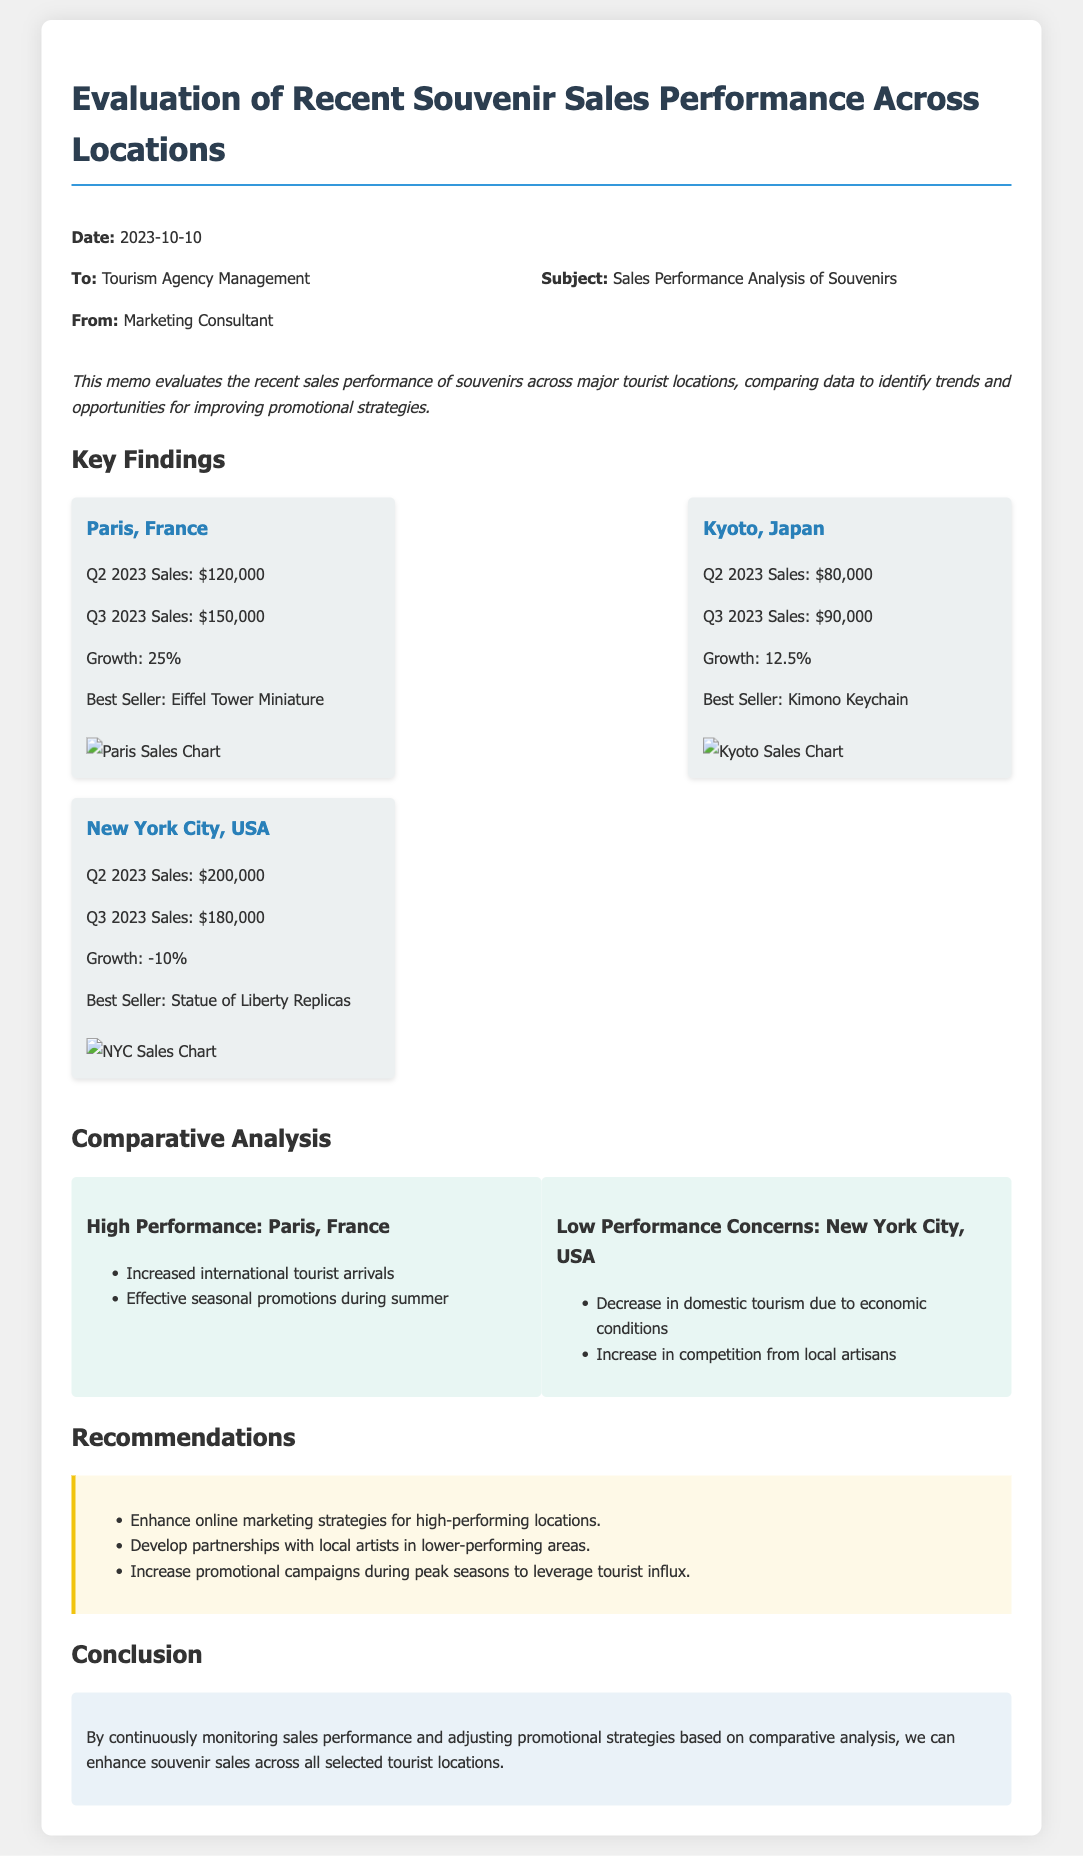What was the sales growth percentage for Paris? The growth for Paris is specifically stated as 25% in the key findings section.
Answer: 25% What is the best-selling souvenir in Kyoto? The document mentions the Kimono Keychain as the best seller in Kyoto.
Answer: Kimono Keychain What were the Q2 2023 sales figures for New York City? The Q2 2023 sales for New York City are provided, which is $200,000.
Answer: $200,000 What are the two main factors mentioned for Paris's high performance? The report lists increased international tourist arrivals and effective seasonal promotions as factors for Paris's success.
Answer: Increased international tourist arrivals, effective seasonal promotions What recommendations are given for low-performing areas? The recommendations included developing partnerships with local artists in areas with lower performance.
Answer: Develop partnerships with local artists What growth trend is observed in Kyoto? The document shows a growth of 12.5% for Kyoto in the recent analysis.
Answer: 12.5% What is the conclusion mentioned in the memo? The conclusion states the importance of monitoring sales performance and adjusting strategies.
Answer: Enhance souvenir sales across all selected tourist locations On what date was the memo issued? The date of the memo is explicitly stated as 2023-10-10.
Answer: 2023-10-10 